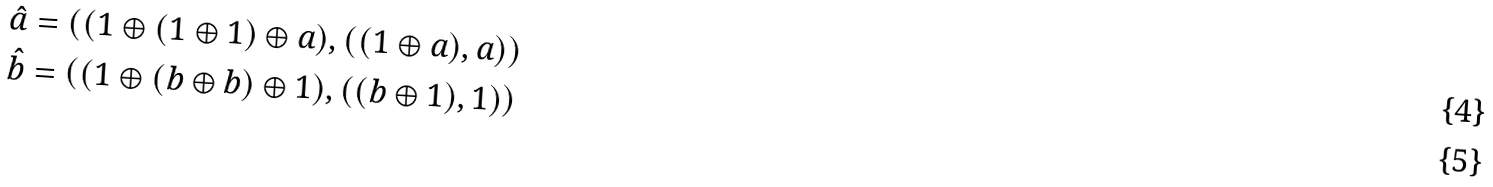<formula> <loc_0><loc_0><loc_500><loc_500>\hat { a } & = \left ( ( 1 \oplus ( 1 \oplus 1 ) \oplus a ) , ( ( 1 \oplus a ) , a ) \right ) \\ \hat { b } & = \left ( ( 1 \oplus ( b \oplus b ) \oplus 1 ) , ( ( b \oplus 1 ) , 1 ) \right )</formula> 